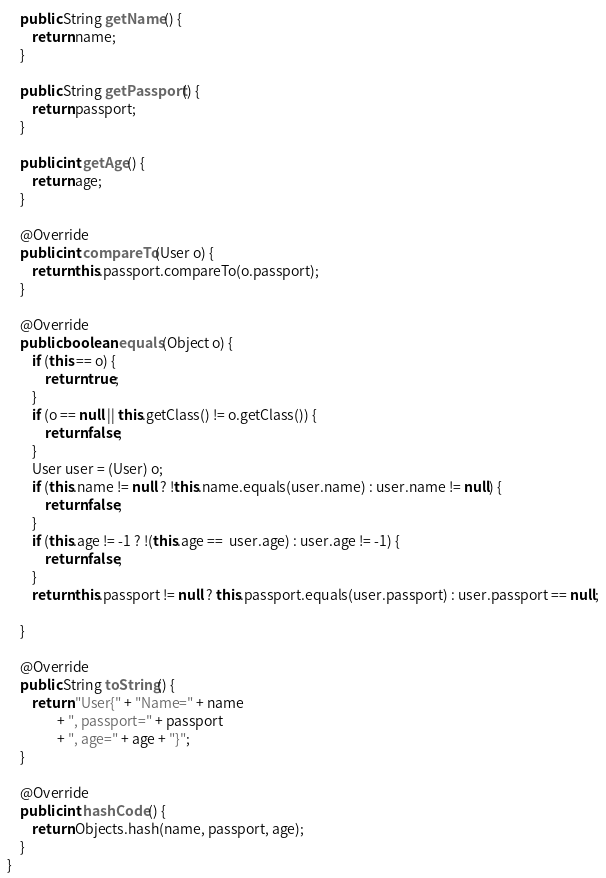Convert code to text. <code><loc_0><loc_0><loc_500><loc_500><_Java_>
    public String getName() {
        return name;
    }

    public String getPassport() {
        return passport;
    }

    public int getAge() {
        return age;
    }

    @Override
    public int compareTo(User o) {
        return this.passport.compareTo(o.passport);
    }

    @Override
    public boolean equals(Object o) {
        if (this == o) {
            return true;
        }
        if (o == null || this.getClass() != o.getClass()) {
            return false;
        }
        User user = (User) o;
        if (this.name != null ? !this.name.equals(user.name) : user.name != null) {
            return false;
        }
        if (this.age != -1 ? !(this.age ==  user.age) : user.age != -1) {
            return false;
        }
        return this.passport != null ? this.passport.equals(user.passport) : user.passport == null;

    }

    @Override
    public String toString() {
        return "User{" + "Name=" + name
                + ", passport=" + passport
                + ", age=" + age + "}";
    }

    @Override
    public int hashCode() {
        return Objects.hash(name, passport, age);
    }
}</code> 